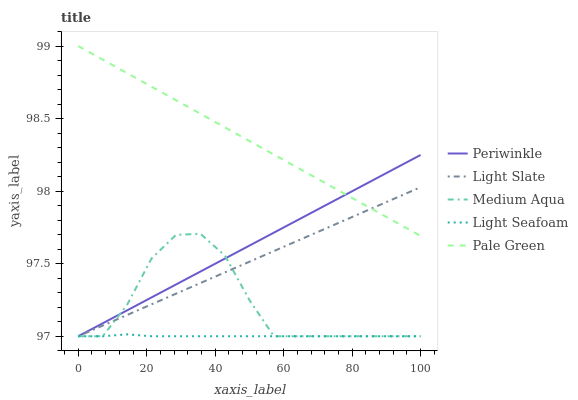Does Light Seafoam have the minimum area under the curve?
Answer yes or no. Yes. Does Pale Green have the maximum area under the curve?
Answer yes or no. Yes. Does Medium Aqua have the minimum area under the curve?
Answer yes or no. No. Does Medium Aqua have the maximum area under the curve?
Answer yes or no. No. Is Light Slate the smoothest?
Answer yes or no. Yes. Is Medium Aqua the roughest?
Answer yes or no. Yes. Is Pale Green the smoothest?
Answer yes or no. No. Is Pale Green the roughest?
Answer yes or no. No. Does Pale Green have the lowest value?
Answer yes or no. No. Does Medium Aqua have the highest value?
Answer yes or no. No. Is Medium Aqua less than Pale Green?
Answer yes or no. Yes. Is Pale Green greater than Light Seafoam?
Answer yes or no. Yes. Does Medium Aqua intersect Pale Green?
Answer yes or no. No. 